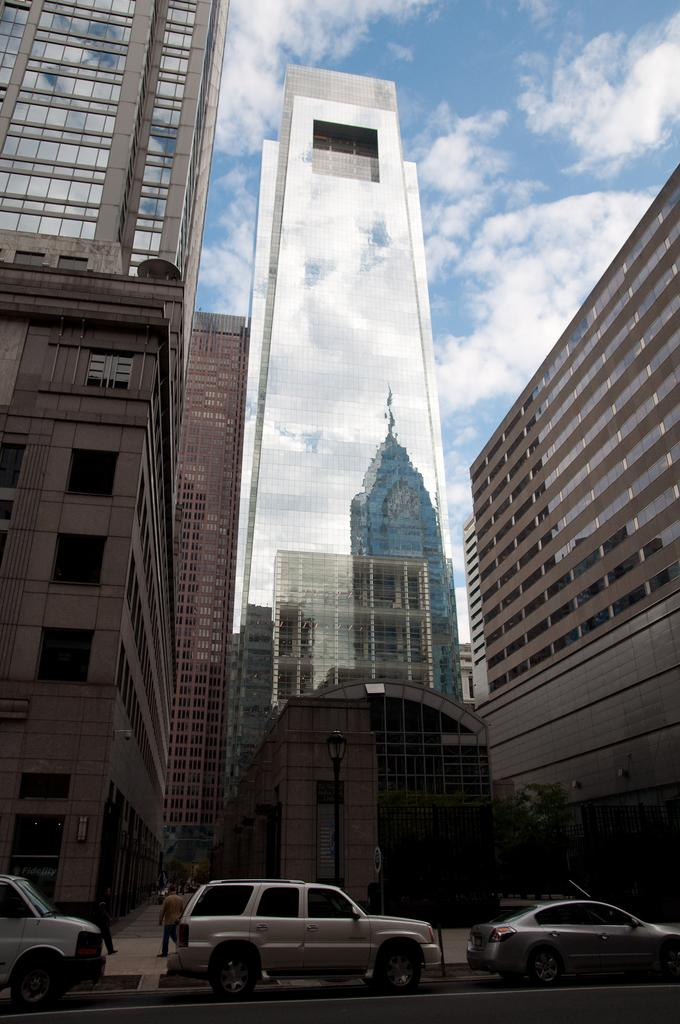What type of vehicles can be seen on the road in the image? There are cars on the road in the image. What can be seen in the distance behind the cars? There are buildings in the background of the image. Who or what is present in the image besides the cars and buildings? There are persons in the image. How would you describe the weather based on the appearance of the sky in the image? The sky is cloudy in the image. What type of effect does the building have on the face of the person in the image? There is no face present in the image, and therefore no effect can be observed on a face. 